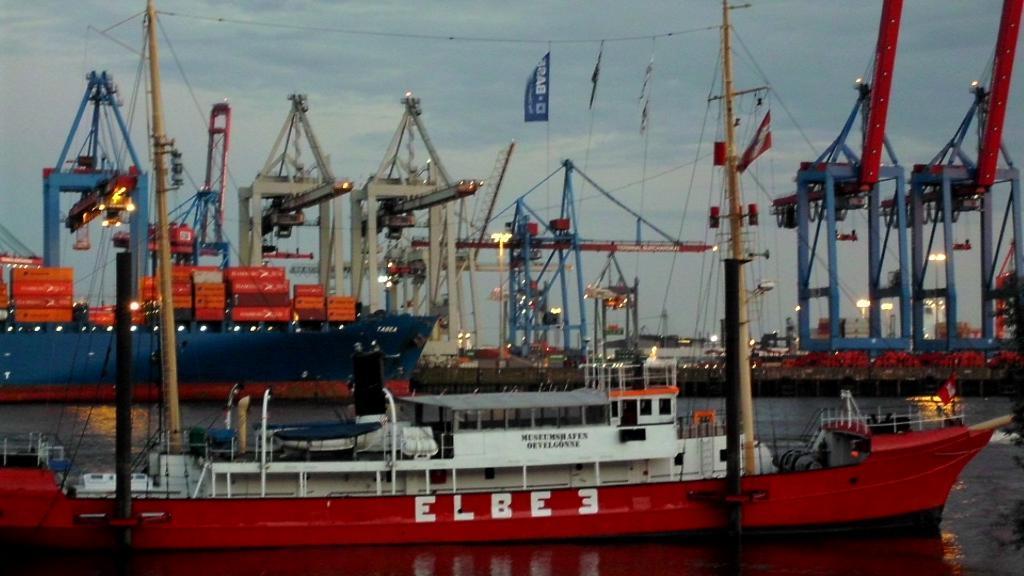In one or two sentences, can you explain what this image depicts? In this picture we can see few ships on the water, and we can find few containers in the ship, in the background we can see few cranes, lights and cables. 